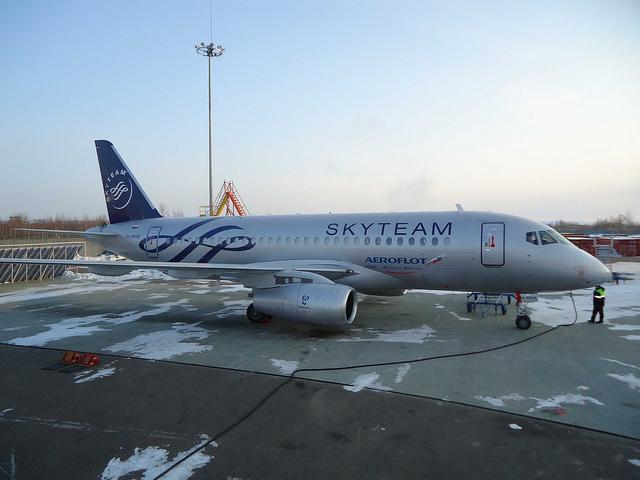How long is the airplane?
Keep it brief. 100 feet. Is the plane on the ground?
Be succinct. Yes. What color is the person's vest?
Short answer required. Green. What airline is this?
Concise answer only. Skyteam. 